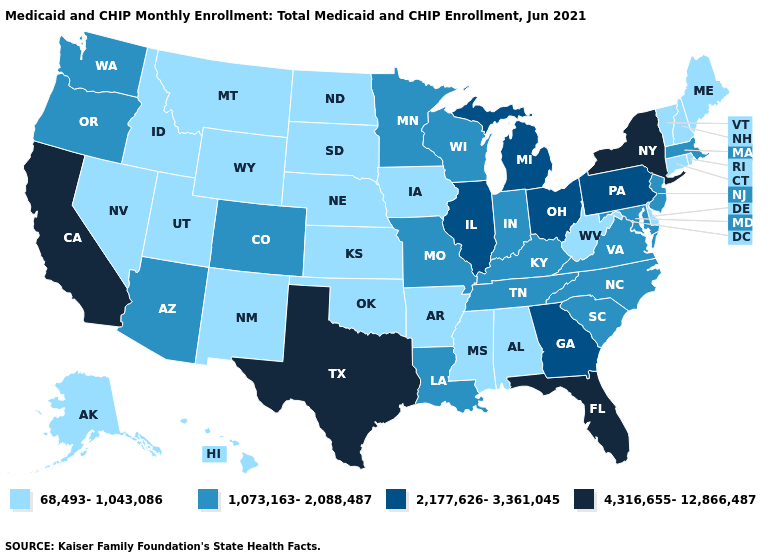Name the states that have a value in the range 4,316,655-12,866,487?
Concise answer only. California, Florida, New York, Texas. What is the value of West Virginia?
Short answer required. 68,493-1,043,086. Does North Dakota have a higher value than Colorado?
Short answer required. No. What is the value of North Carolina?
Short answer required. 1,073,163-2,088,487. Does Oklahoma have the same value as Mississippi?
Concise answer only. Yes. Name the states that have a value in the range 68,493-1,043,086?
Be succinct. Alabama, Alaska, Arkansas, Connecticut, Delaware, Hawaii, Idaho, Iowa, Kansas, Maine, Mississippi, Montana, Nebraska, Nevada, New Hampshire, New Mexico, North Dakota, Oklahoma, Rhode Island, South Dakota, Utah, Vermont, West Virginia, Wyoming. What is the value of Virginia?
Write a very short answer. 1,073,163-2,088,487. What is the value of Oklahoma?
Quick response, please. 68,493-1,043,086. What is the value of Ohio?
Keep it brief. 2,177,626-3,361,045. How many symbols are there in the legend?
Write a very short answer. 4. Which states hav the highest value in the South?
Answer briefly. Florida, Texas. What is the highest value in states that border Montana?
Short answer required. 68,493-1,043,086. Does West Virginia have the lowest value in the USA?
Quick response, please. Yes. Among the states that border Indiana , which have the lowest value?
Write a very short answer. Kentucky. What is the highest value in states that border Delaware?
Give a very brief answer. 2,177,626-3,361,045. 